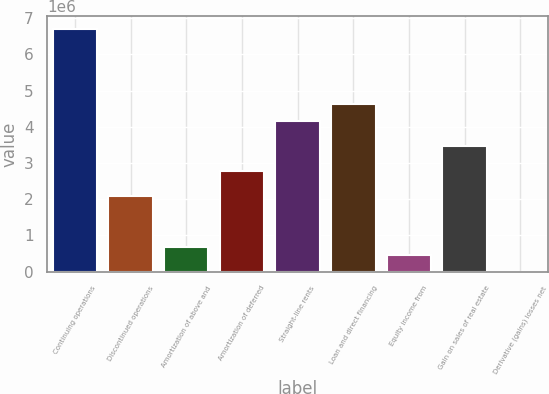<chart> <loc_0><loc_0><loc_500><loc_500><bar_chart><fcel>Continuing operations<fcel>Discontinued operations<fcel>Amortization of above and<fcel>Amortization of deferred<fcel>Straight-line rents<fcel>Loan and direct financing<fcel>Equity income from<fcel>Gain on sales of real estate<fcel>Derivative (gains) losses net<nl><fcel>6.71096e+06<fcel>2.08274e+06<fcel>694276<fcel>2.77697e+06<fcel>4.16544e+06<fcel>4.62826e+06<fcel>462865<fcel>3.47121e+06<fcel>43<nl></chart> 